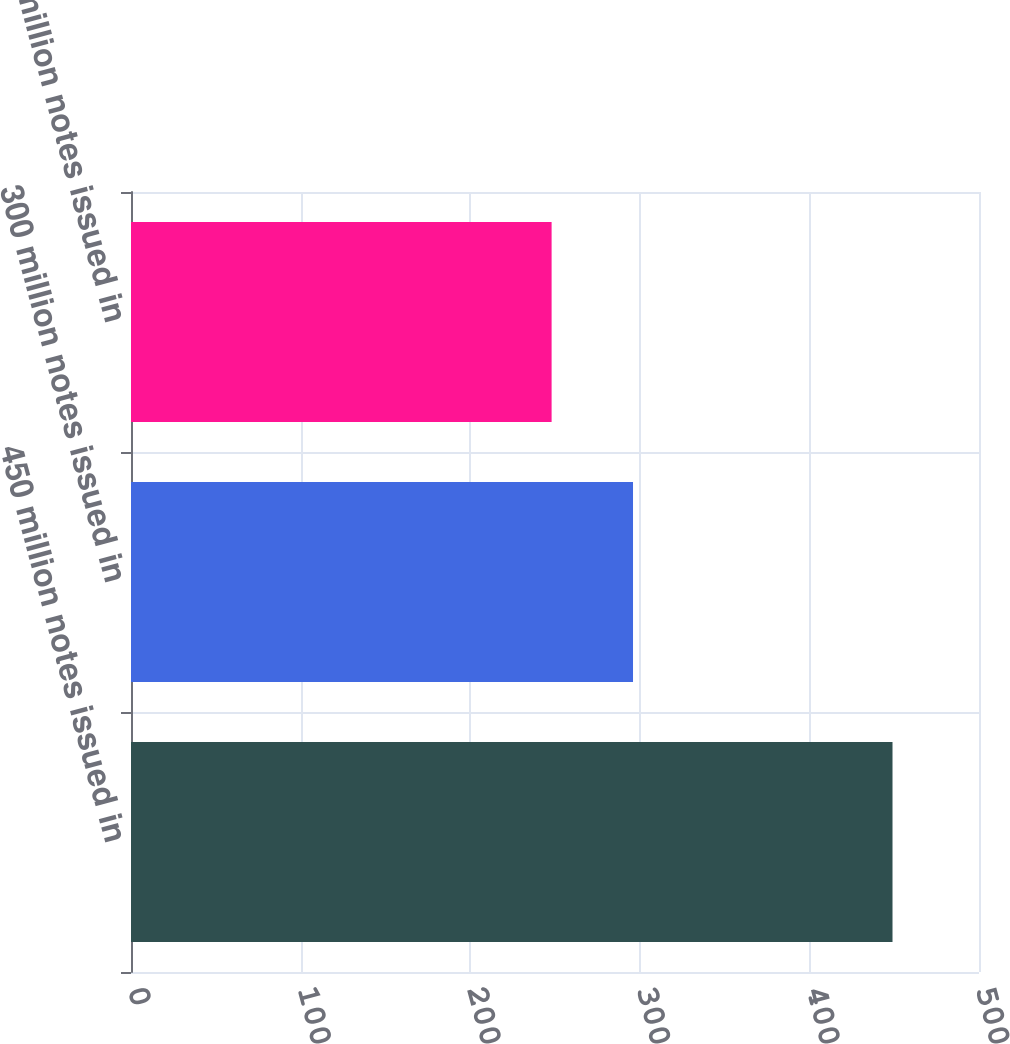<chart> <loc_0><loc_0><loc_500><loc_500><bar_chart><fcel>450 million notes issued in<fcel>300 million notes issued in<fcel>250 million notes issued in<nl><fcel>449<fcel>296<fcel>248<nl></chart> 